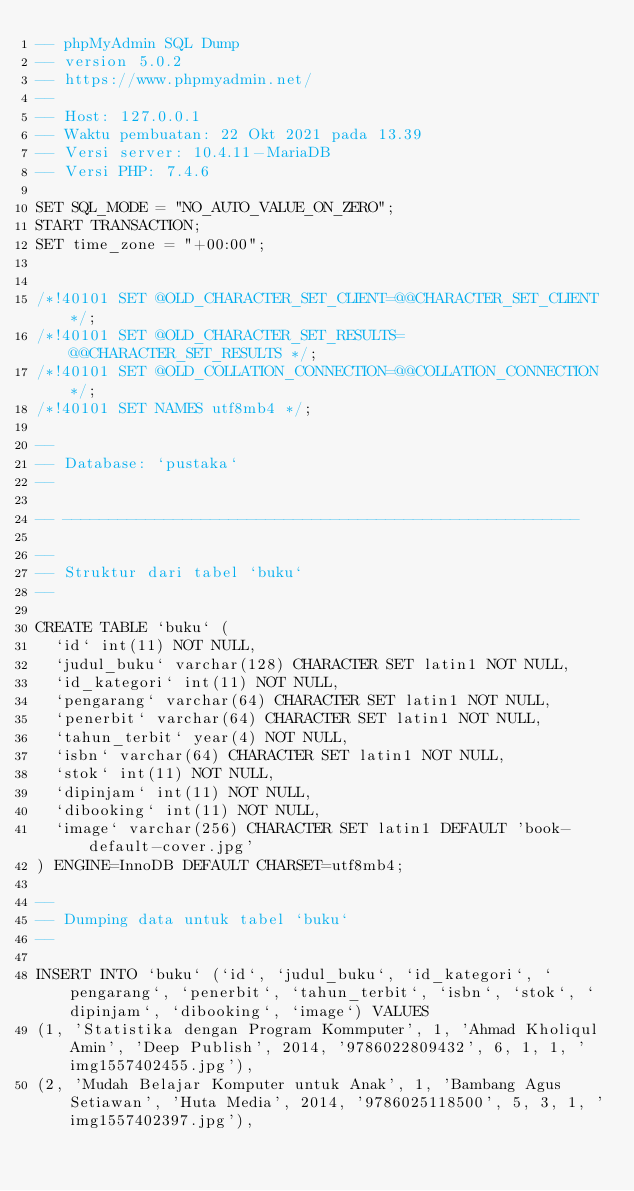Convert code to text. <code><loc_0><loc_0><loc_500><loc_500><_SQL_>-- phpMyAdmin SQL Dump
-- version 5.0.2
-- https://www.phpmyadmin.net/
--
-- Host: 127.0.0.1
-- Waktu pembuatan: 22 Okt 2021 pada 13.39
-- Versi server: 10.4.11-MariaDB
-- Versi PHP: 7.4.6

SET SQL_MODE = "NO_AUTO_VALUE_ON_ZERO";
START TRANSACTION;
SET time_zone = "+00:00";


/*!40101 SET @OLD_CHARACTER_SET_CLIENT=@@CHARACTER_SET_CLIENT */;
/*!40101 SET @OLD_CHARACTER_SET_RESULTS=@@CHARACTER_SET_RESULTS */;
/*!40101 SET @OLD_COLLATION_CONNECTION=@@COLLATION_CONNECTION */;
/*!40101 SET NAMES utf8mb4 */;

--
-- Database: `pustaka`
--

-- --------------------------------------------------------

--
-- Struktur dari tabel `buku`
--

CREATE TABLE `buku` (
  `id` int(11) NOT NULL,
  `judul_buku` varchar(128) CHARACTER SET latin1 NOT NULL,
  `id_kategori` int(11) NOT NULL,
  `pengarang` varchar(64) CHARACTER SET latin1 NOT NULL,
  `penerbit` varchar(64) CHARACTER SET latin1 NOT NULL,
  `tahun_terbit` year(4) NOT NULL,
  `isbn` varchar(64) CHARACTER SET latin1 NOT NULL,
  `stok` int(11) NOT NULL,
  `dipinjam` int(11) NOT NULL,
  `dibooking` int(11) NOT NULL,
  `image` varchar(256) CHARACTER SET latin1 DEFAULT 'book-default-cover.jpg'
) ENGINE=InnoDB DEFAULT CHARSET=utf8mb4;

--
-- Dumping data untuk tabel `buku`
--

INSERT INTO `buku` (`id`, `judul_buku`, `id_kategori`, `pengarang`, `penerbit`, `tahun_terbit`, `isbn`, `stok`, `dipinjam`, `dibooking`, `image`) VALUES
(1, 'Statistika dengan Program Kommputer', 1, 'Ahmad Kholiqul Amin', 'Deep Publish', 2014, '9786022809432', 6, 1, 1, 'img1557402455.jpg'),
(2, 'Mudah Belajar Komputer untuk Anak', 1, 'Bambang Agus Setiawan', 'Huta Media', 2014, '9786025118500', 5, 3, 1, 'img1557402397.jpg'),</code> 